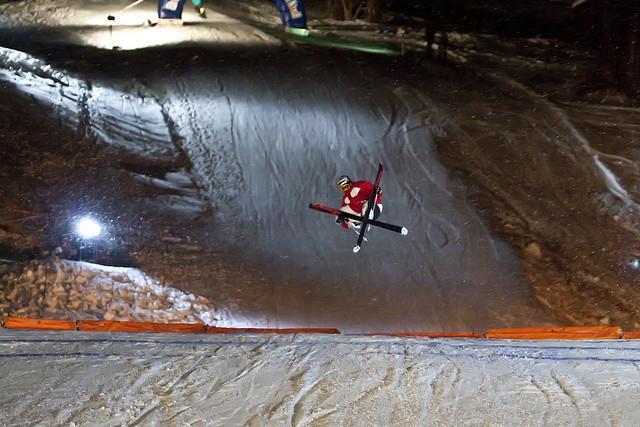How many people skiing?
Give a very brief answer. 1. How many light color cars are there?
Give a very brief answer. 0. 